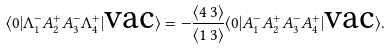Convert formula to latex. <formula><loc_0><loc_0><loc_500><loc_500>\langle 0 | \Lambda _ { 1 } ^ { - } A _ { 2 } ^ { + } A _ { 3 } ^ { - } \Lambda _ { 4 } ^ { + } | \text {vac} \rangle = - \frac { \langle 4 \, 3 \rangle } { \langle 1 \, 3 \rangle } \langle 0 | A _ { 1 } ^ { - } A _ { 2 } ^ { + } A _ { 3 } ^ { - } A _ { 4 } ^ { + } | \text {vac} \rangle .</formula> 